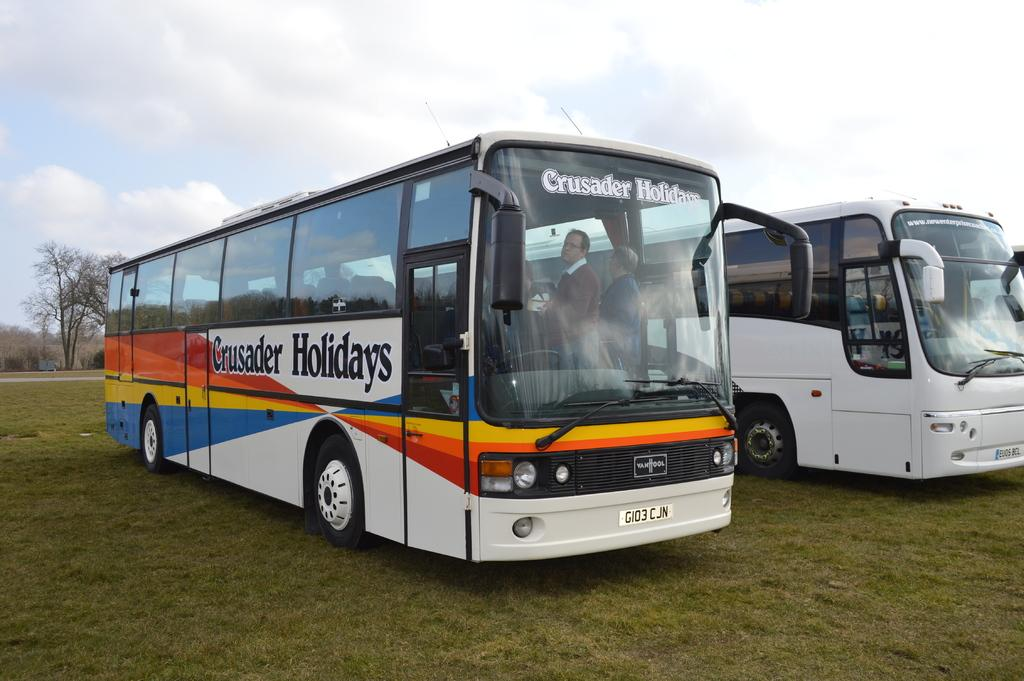What types of objects are on the ground in the image? There are vehicles on the ground in the image. What can be seen in the distance behind the vehicles? Trees and the sky are visible in the background of the image. How many yaks are grazing in the background of the image? There are no yaks present in the image; only trees and the sky are visible in the background. 